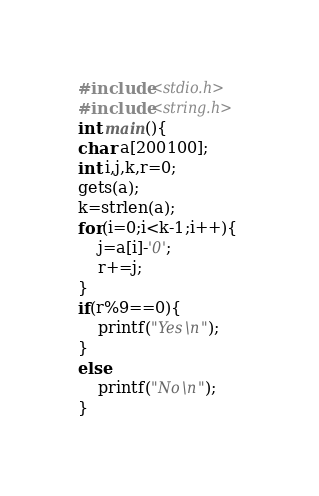Convert code to text. <code><loc_0><loc_0><loc_500><loc_500><_C_>#include<stdio.h>
#include<string.h>
int main(){
char a[200100];
int i,j,k,r=0;
gets(a);
k=strlen(a);
for(i=0;i<k-1;i++){
    j=a[i]-'0';
    r+=j;
}
if(r%9==0){
    printf("Yes\n");
}
else
    printf("No\n");
}
</code> 